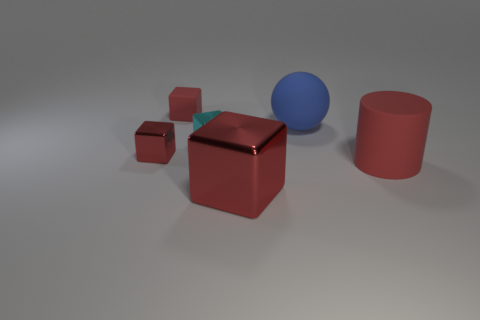There is a metal thing that is in front of the red rubber thing in front of the large matte sphere; what color is it?
Offer a terse response. Red. What number of large objects are cyan things or gray matte cylinders?
Provide a short and direct response. 0. What number of small cyan objects are made of the same material as the large sphere?
Provide a short and direct response. 0. There is a cyan shiny thing that is behind the cylinder; what is its size?
Provide a short and direct response. Small. There is a thing that is on the left side of the red matte thing behind the rubber sphere; what shape is it?
Provide a succinct answer. Cube. There is a red cube in front of the red rubber object that is right of the cyan shiny block; what number of big things are to the left of it?
Offer a very short reply. 0. Are there fewer blue rubber spheres in front of the big red block than red cubes?
Provide a short and direct response. Yes. Is there any other thing that has the same shape as the small red metallic object?
Provide a short and direct response. Yes. What shape is the red metallic thing that is in front of the large rubber cylinder?
Your answer should be very brief. Cube. There is a small red object behind the large sphere that is behind the red metallic thing that is behind the big red cylinder; what is its shape?
Ensure brevity in your answer.  Cube. 